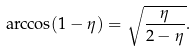<formula> <loc_0><loc_0><loc_500><loc_500>\arccos ( 1 - \eta ) = \sqrt { \frac { \eta } { 2 - \eta } } .</formula> 